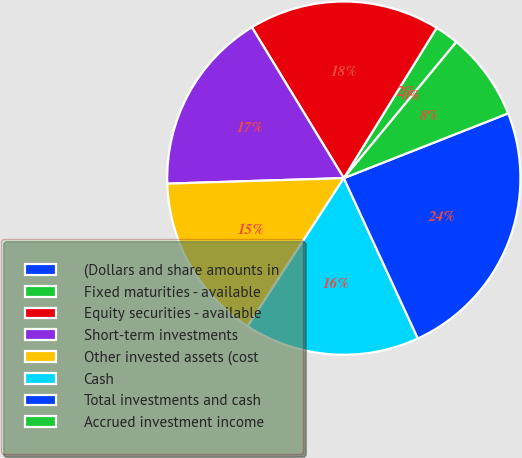Convert chart to OTSL. <chart><loc_0><loc_0><loc_500><loc_500><pie_chart><fcel>(Dollars and share amounts in<fcel>Fixed maturities - available<fcel>Equity securities - available<fcel>Short-term investments<fcel>Other invested assets (cost<fcel>Cash<fcel>Total investments and cash<fcel>Accrued investment income<nl><fcel>0.0%<fcel>2.19%<fcel>17.52%<fcel>16.79%<fcel>15.33%<fcel>16.06%<fcel>24.09%<fcel>8.03%<nl></chart> 